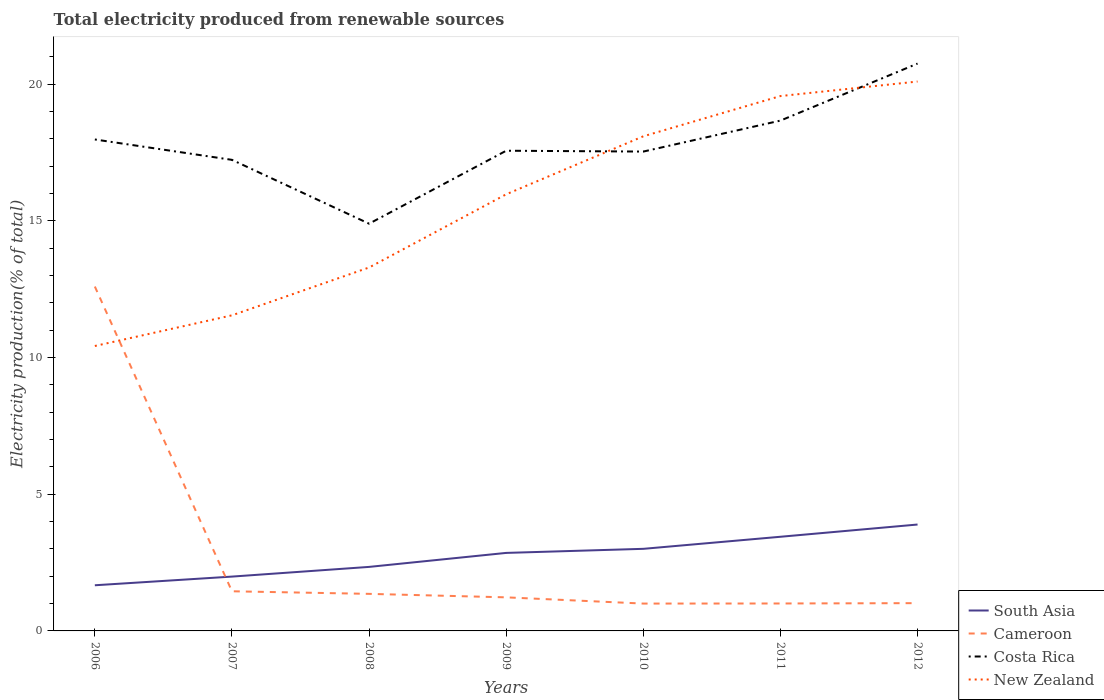How many different coloured lines are there?
Provide a succinct answer. 4. Is the number of lines equal to the number of legend labels?
Your answer should be compact. Yes. Across all years, what is the maximum total electricity produced in Cameroon?
Your response must be concise. 1. What is the total total electricity produced in Costa Rica in the graph?
Your answer should be compact. -3.52. What is the difference between the highest and the second highest total electricity produced in Cameroon?
Ensure brevity in your answer.  11.59. What is the difference between the highest and the lowest total electricity produced in Cameroon?
Give a very brief answer. 1. How are the legend labels stacked?
Offer a terse response. Vertical. What is the title of the graph?
Provide a succinct answer. Total electricity produced from renewable sources. Does "Andorra" appear as one of the legend labels in the graph?
Your answer should be compact. No. What is the Electricity production(% of total) of South Asia in 2006?
Your answer should be very brief. 1.67. What is the Electricity production(% of total) of Cameroon in 2006?
Keep it short and to the point. 12.59. What is the Electricity production(% of total) in Costa Rica in 2006?
Provide a short and direct response. 17.97. What is the Electricity production(% of total) of New Zealand in 2006?
Keep it short and to the point. 10.42. What is the Electricity production(% of total) in South Asia in 2007?
Offer a very short reply. 1.99. What is the Electricity production(% of total) in Cameroon in 2007?
Your answer should be compact. 1.45. What is the Electricity production(% of total) in Costa Rica in 2007?
Offer a terse response. 17.23. What is the Electricity production(% of total) of New Zealand in 2007?
Offer a very short reply. 11.54. What is the Electricity production(% of total) in South Asia in 2008?
Offer a terse response. 2.34. What is the Electricity production(% of total) in Cameroon in 2008?
Your answer should be compact. 1.36. What is the Electricity production(% of total) in Costa Rica in 2008?
Make the answer very short. 14.89. What is the Electricity production(% of total) in New Zealand in 2008?
Give a very brief answer. 13.29. What is the Electricity production(% of total) in South Asia in 2009?
Your answer should be very brief. 2.85. What is the Electricity production(% of total) of Cameroon in 2009?
Your answer should be compact. 1.23. What is the Electricity production(% of total) of Costa Rica in 2009?
Keep it short and to the point. 17.56. What is the Electricity production(% of total) of New Zealand in 2009?
Provide a succinct answer. 15.97. What is the Electricity production(% of total) in South Asia in 2010?
Keep it short and to the point. 3. What is the Electricity production(% of total) in Cameroon in 2010?
Your answer should be very brief. 1. What is the Electricity production(% of total) in Costa Rica in 2010?
Ensure brevity in your answer.  17.53. What is the Electricity production(% of total) of New Zealand in 2010?
Your response must be concise. 18.09. What is the Electricity production(% of total) in South Asia in 2011?
Your response must be concise. 3.44. What is the Electricity production(% of total) of Cameroon in 2011?
Make the answer very short. 1. What is the Electricity production(% of total) of Costa Rica in 2011?
Your answer should be very brief. 18.66. What is the Electricity production(% of total) in New Zealand in 2011?
Your answer should be compact. 19.56. What is the Electricity production(% of total) of South Asia in 2012?
Your response must be concise. 3.89. What is the Electricity production(% of total) of Cameroon in 2012?
Your response must be concise. 1.02. What is the Electricity production(% of total) in Costa Rica in 2012?
Your answer should be very brief. 20.75. What is the Electricity production(% of total) of New Zealand in 2012?
Offer a terse response. 20.09. Across all years, what is the maximum Electricity production(% of total) in South Asia?
Provide a succinct answer. 3.89. Across all years, what is the maximum Electricity production(% of total) in Cameroon?
Provide a short and direct response. 12.59. Across all years, what is the maximum Electricity production(% of total) of Costa Rica?
Keep it short and to the point. 20.75. Across all years, what is the maximum Electricity production(% of total) of New Zealand?
Offer a terse response. 20.09. Across all years, what is the minimum Electricity production(% of total) in South Asia?
Provide a short and direct response. 1.67. Across all years, what is the minimum Electricity production(% of total) in Cameroon?
Provide a short and direct response. 1. Across all years, what is the minimum Electricity production(% of total) of Costa Rica?
Provide a short and direct response. 14.89. Across all years, what is the minimum Electricity production(% of total) in New Zealand?
Give a very brief answer. 10.42. What is the total Electricity production(% of total) in South Asia in the graph?
Make the answer very short. 19.19. What is the total Electricity production(% of total) of Cameroon in the graph?
Your response must be concise. 19.64. What is the total Electricity production(% of total) in Costa Rica in the graph?
Offer a terse response. 124.59. What is the total Electricity production(% of total) in New Zealand in the graph?
Offer a very short reply. 108.95. What is the difference between the Electricity production(% of total) in South Asia in 2006 and that in 2007?
Provide a succinct answer. -0.32. What is the difference between the Electricity production(% of total) in Cameroon in 2006 and that in 2007?
Keep it short and to the point. 11.14. What is the difference between the Electricity production(% of total) in Costa Rica in 2006 and that in 2007?
Give a very brief answer. 0.75. What is the difference between the Electricity production(% of total) in New Zealand in 2006 and that in 2007?
Your answer should be very brief. -1.12. What is the difference between the Electricity production(% of total) of South Asia in 2006 and that in 2008?
Your answer should be very brief. -0.67. What is the difference between the Electricity production(% of total) of Cameroon in 2006 and that in 2008?
Your response must be concise. 11.24. What is the difference between the Electricity production(% of total) of Costa Rica in 2006 and that in 2008?
Your answer should be very brief. 3.08. What is the difference between the Electricity production(% of total) in New Zealand in 2006 and that in 2008?
Give a very brief answer. -2.87. What is the difference between the Electricity production(% of total) in South Asia in 2006 and that in 2009?
Keep it short and to the point. -1.18. What is the difference between the Electricity production(% of total) of Cameroon in 2006 and that in 2009?
Ensure brevity in your answer.  11.37. What is the difference between the Electricity production(% of total) in Costa Rica in 2006 and that in 2009?
Provide a short and direct response. 0.41. What is the difference between the Electricity production(% of total) in New Zealand in 2006 and that in 2009?
Give a very brief answer. -5.55. What is the difference between the Electricity production(% of total) in South Asia in 2006 and that in 2010?
Ensure brevity in your answer.  -1.33. What is the difference between the Electricity production(% of total) of Cameroon in 2006 and that in 2010?
Provide a succinct answer. 11.59. What is the difference between the Electricity production(% of total) of Costa Rica in 2006 and that in 2010?
Provide a short and direct response. 0.44. What is the difference between the Electricity production(% of total) in New Zealand in 2006 and that in 2010?
Keep it short and to the point. -7.67. What is the difference between the Electricity production(% of total) in South Asia in 2006 and that in 2011?
Offer a terse response. -1.77. What is the difference between the Electricity production(% of total) in Cameroon in 2006 and that in 2011?
Give a very brief answer. 11.59. What is the difference between the Electricity production(% of total) in Costa Rica in 2006 and that in 2011?
Offer a terse response. -0.69. What is the difference between the Electricity production(% of total) of New Zealand in 2006 and that in 2011?
Provide a succinct answer. -9.14. What is the difference between the Electricity production(% of total) in South Asia in 2006 and that in 2012?
Make the answer very short. -2.22. What is the difference between the Electricity production(% of total) of Cameroon in 2006 and that in 2012?
Your answer should be compact. 11.58. What is the difference between the Electricity production(% of total) in Costa Rica in 2006 and that in 2012?
Make the answer very short. -2.78. What is the difference between the Electricity production(% of total) of New Zealand in 2006 and that in 2012?
Your answer should be compact. -9.67. What is the difference between the Electricity production(% of total) of South Asia in 2007 and that in 2008?
Provide a succinct answer. -0.35. What is the difference between the Electricity production(% of total) of Cameroon in 2007 and that in 2008?
Offer a very short reply. 0.09. What is the difference between the Electricity production(% of total) in Costa Rica in 2007 and that in 2008?
Give a very brief answer. 2.33. What is the difference between the Electricity production(% of total) in New Zealand in 2007 and that in 2008?
Provide a short and direct response. -1.75. What is the difference between the Electricity production(% of total) in South Asia in 2007 and that in 2009?
Give a very brief answer. -0.87. What is the difference between the Electricity production(% of total) of Cameroon in 2007 and that in 2009?
Offer a terse response. 0.22. What is the difference between the Electricity production(% of total) of Costa Rica in 2007 and that in 2009?
Ensure brevity in your answer.  -0.33. What is the difference between the Electricity production(% of total) in New Zealand in 2007 and that in 2009?
Give a very brief answer. -4.43. What is the difference between the Electricity production(% of total) of South Asia in 2007 and that in 2010?
Ensure brevity in your answer.  -1.01. What is the difference between the Electricity production(% of total) in Cameroon in 2007 and that in 2010?
Ensure brevity in your answer.  0.45. What is the difference between the Electricity production(% of total) in Costa Rica in 2007 and that in 2010?
Make the answer very short. -0.3. What is the difference between the Electricity production(% of total) in New Zealand in 2007 and that in 2010?
Keep it short and to the point. -6.55. What is the difference between the Electricity production(% of total) in South Asia in 2007 and that in 2011?
Keep it short and to the point. -1.46. What is the difference between the Electricity production(% of total) in Cameroon in 2007 and that in 2011?
Offer a very short reply. 0.45. What is the difference between the Electricity production(% of total) of Costa Rica in 2007 and that in 2011?
Offer a very short reply. -1.44. What is the difference between the Electricity production(% of total) of New Zealand in 2007 and that in 2011?
Give a very brief answer. -8.02. What is the difference between the Electricity production(% of total) of South Asia in 2007 and that in 2012?
Offer a terse response. -1.9. What is the difference between the Electricity production(% of total) of Cameroon in 2007 and that in 2012?
Provide a short and direct response. 0.43. What is the difference between the Electricity production(% of total) of Costa Rica in 2007 and that in 2012?
Provide a short and direct response. -3.52. What is the difference between the Electricity production(% of total) in New Zealand in 2007 and that in 2012?
Offer a terse response. -8.55. What is the difference between the Electricity production(% of total) of South Asia in 2008 and that in 2009?
Your response must be concise. -0.51. What is the difference between the Electricity production(% of total) of Cameroon in 2008 and that in 2009?
Keep it short and to the point. 0.13. What is the difference between the Electricity production(% of total) in Costa Rica in 2008 and that in 2009?
Ensure brevity in your answer.  -2.67. What is the difference between the Electricity production(% of total) in New Zealand in 2008 and that in 2009?
Offer a very short reply. -2.68. What is the difference between the Electricity production(% of total) of South Asia in 2008 and that in 2010?
Your answer should be compact. -0.66. What is the difference between the Electricity production(% of total) of Cameroon in 2008 and that in 2010?
Ensure brevity in your answer.  0.36. What is the difference between the Electricity production(% of total) in Costa Rica in 2008 and that in 2010?
Keep it short and to the point. -2.64. What is the difference between the Electricity production(% of total) of New Zealand in 2008 and that in 2010?
Give a very brief answer. -4.8. What is the difference between the Electricity production(% of total) of South Asia in 2008 and that in 2011?
Keep it short and to the point. -1.1. What is the difference between the Electricity production(% of total) in Cameroon in 2008 and that in 2011?
Your answer should be very brief. 0.35. What is the difference between the Electricity production(% of total) in Costa Rica in 2008 and that in 2011?
Your answer should be very brief. -3.77. What is the difference between the Electricity production(% of total) of New Zealand in 2008 and that in 2011?
Your answer should be compact. -6.27. What is the difference between the Electricity production(% of total) of South Asia in 2008 and that in 2012?
Keep it short and to the point. -1.55. What is the difference between the Electricity production(% of total) of Cameroon in 2008 and that in 2012?
Ensure brevity in your answer.  0.34. What is the difference between the Electricity production(% of total) in Costa Rica in 2008 and that in 2012?
Your answer should be compact. -5.86. What is the difference between the Electricity production(% of total) of New Zealand in 2008 and that in 2012?
Your answer should be very brief. -6.8. What is the difference between the Electricity production(% of total) in South Asia in 2009 and that in 2010?
Provide a succinct answer. -0.15. What is the difference between the Electricity production(% of total) in Cameroon in 2009 and that in 2010?
Your answer should be compact. 0.23. What is the difference between the Electricity production(% of total) of Costa Rica in 2009 and that in 2010?
Your answer should be very brief. 0.03. What is the difference between the Electricity production(% of total) of New Zealand in 2009 and that in 2010?
Your response must be concise. -2.12. What is the difference between the Electricity production(% of total) in South Asia in 2009 and that in 2011?
Provide a short and direct response. -0.59. What is the difference between the Electricity production(% of total) of Cameroon in 2009 and that in 2011?
Make the answer very short. 0.22. What is the difference between the Electricity production(% of total) in Costa Rica in 2009 and that in 2011?
Provide a succinct answer. -1.1. What is the difference between the Electricity production(% of total) in New Zealand in 2009 and that in 2011?
Give a very brief answer. -3.59. What is the difference between the Electricity production(% of total) in South Asia in 2009 and that in 2012?
Make the answer very short. -1.04. What is the difference between the Electricity production(% of total) of Cameroon in 2009 and that in 2012?
Your answer should be very brief. 0.21. What is the difference between the Electricity production(% of total) in Costa Rica in 2009 and that in 2012?
Provide a succinct answer. -3.19. What is the difference between the Electricity production(% of total) in New Zealand in 2009 and that in 2012?
Provide a succinct answer. -4.12. What is the difference between the Electricity production(% of total) of South Asia in 2010 and that in 2011?
Offer a very short reply. -0.44. What is the difference between the Electricity production(% of total) of Cameroon in 2010 and that in 2011?
Make the answer very short. -0. What is the difference between the Electricity production(% of total) in Costa Rica in 2010 and that in 2011?
Your answer should be compact. -1.13. What is the difference between the Electricity production(% of total) in New Zealand in 2010 and that in 2011?
Your answer should be very brief. -1.47. What is the difference between the Electricity production(% of total) in South Asia in 2010 and that in 2012?
Your answer should be compact. -0.89. What is the difference between the Electricity production(% of total) in Cameroon in 2010 and that in 2012?
Give a very brief answer. -0.02. What is the difference between the Electricity production(% of total) of Costa Rica in 2010 and that in 2012?
Your response must be concise. -3.22. What is the difference between the Electricity production(% of total) of New Zealand in 2010 and that in 2012?
Give a very brief answer. -2. What is the difference between the Electricity production(% of total) in South Asia in 2011 and that in 2012?
Your response must be concise. -0.45. What is the difference between the Electricity production(% of total) in Cameroon in 2011 and that in 2012?
Offer a very short reply. -0.01. What is the difference between the Electricity production(% of total) in Costa Rica in 2011 and that in 2012?
Offer a terse response. -2.09. What is the difference between the Electricity production(% of total) in New Zealand in 2011 and that in 2012?
Offer a terse response. -0.53. What is the difference between the Electricity production(% of total) in South Asia in 2006 and the Electricity production(% of total) in Cameroon in 2007?
Your answer should be very brief. 0.22. What is the difference between the Electricity production(% of total) of South Asia in 2006 and the Electricity production(% of total) of Costa Rica in 2007?
Offer a very short reply. -15.56. What is the difference between the Electricity production(% of total) in South Asia in 2006 and the Electricity production(% of total) in New Zealand in 2007?
Make the answer very short. -9.87. What is the difference between the Electricity production(% of total) in Cameroon in 2006 and the Electricity production(% of total) in Costa Rica in 2007?
Keep it short and to the point. -4.63. What is the difference between the Electricity production(% of total) in Cameroon in 2006 and the Electricity production(% of total) in New Zealand in 2007?
Your answer should be very brief. 1.05. What is the difference between the Electricity production(% of total) in Costa Rica in 2006 and the Electricity production(% of total) in New Zealand in 2007?
Ensure brevity in your answer.  6.43. What is the difference between the Electricity production(% of total) of South Asia in 2006 and the Electricity production(% of total) of Cameroon in 2008?
Keep it short and to the point. 0.31. What is the difference between the Electricity production(% of total) of South Asia in 2006 and the Electricity production(% of total) of Costa Rica in 2008?
Ensure brevity in your answer.  -13.22. What is the difference between the Electricity production(% of total) in South Asia in 2006 and the Electricity production(% of total) in New Zealand in 2008?
Provide a succinct answer. -11.62. What is the difference between the Electricity production(% of total) of Cameroon in 2006 and the Electricity production(% of total) of Costa Rica in 2008?
Provide a succinct answer. -2.3. What is the difference between the Electricity production(% of total) in Cameroon in 2006 and the Electricity production(% of total) in New Zealand in 2008?
Ensure brevity in your answer.  -0.7. What is the difference between the Electricity production(% of total) in Costa Rica in 2006 and the Electricity production(% of total) in New Zealand in 2008?
Keep it short and to the point. 4.68. What is the difference between the Electricity production(% of total) of South Asia in 2006 and the Electricity production(% of total) of Cameroon in 2009?
Keep it short and to the point. 0.44. What is the difference between the Electricity production(% of total) of South Asia in 2006 and the Electricity production(% of total) of Costa Rica in 2009?
Give a very brief answer. -15.89. What is the difference between the Electricity production(% of total) in South Asia in 2006 and the Electricity production(% of total) in New Zealand in 2009?
Your answer should be compact. -14.3. What is the difference between the Electricity production(% of total) of Cameroon in 2006 and the Electricity production(% of total) of Costa Rica in 2009?
Offer a very short reply. -4.97. What is the difference between the Electricity production(% of total) of Cameroon in 2006 and the Electricity production(% of total) of New Zealand in 2009?
Offer a very short reply. -3.37. What is the difference between the Electricity production(% of total) in Costa Rica in 2006 and the Electricity production(% of total) in New Zealand in 2009?
Provide a succinct answer. 2. What is the difference between the Electricity production(% of total) in South Asia in 2006 and the Electricity production(% of total) in Cameroon in 2010?
Your response must be concise. 0.67. What is the difference between the Electricity production(% of total) in South Asia in 2006 and the Electricity production(% of total) in Costa Rica in 2010?
Keep it short and to the point. -15.86. What is the difference between the Electricity production(% of total) of South Asia in 2006 and the Electricity production(% of total) of New Zealand in 2010?
Your answer should be very brief. -16.42. What is the difference between the Electricity production(% of total) in Cameroon in 2006 and the Electricity production(% of total) in Costa Rica in 2010?
Your answer should be very brief. -4.94. What is the difference between the Electricity production(% of total) in Cameroon in 2006 and the Electricity production(% of total) in New Zealand in 2010?
Provide a short and direct response. -5.49. What is the difference between the Electricity production(% of total) of Costa Rica in 2006 and the Electricity production(% of total) of New Zealand in 2010?
Make the answer very short. -0.12. What is the difference between the Electricity production(% of total) in South Asia in 2006 and the Electricity production(% of total) in Cameroon in 2011?
Keep it short and to the point. 0.67. What is the difference between the Electricity production(% of total) of South Asia in 2006 and the Electricity production(% of total) of Costa Rica in 2011?
Give a very brief answer. -16.99. What is the difference between the Electricity production(% of total) in South Asia in 2006 and the Electricity production(% of total) in New Zealand in 2011?
Your answer should be very brief. -17.89. What is the difference between the Electricity production(% of total) of Cameroon in 2006 and the Electricity production(% of total) of Costa Rica in 2011?
Your answer should be compact. -6.07. What is the difference between the Electricity production(% of total) in Cameroon in 2006 and the Electricity production(% of total) in New Zealand in 2011?
Offer a terse response. -6.97. What is the difference between the Electricity production(% of total) in Costa Rica in 2006 and the Electricity production(% of total) in New Zealand in 2011?
Provide a succinct answer. -1.59. What is the difference between the Electricity production(% of total) of South Asia in 2006 and the Electricity production(% of total) of Cameroon in 2012?
Offer a terse response. 0.65. What is the difference between the Electricity production(% of total) of South Asia in 2006 and the Electricity production(% of total) of Costa Rica in 2012?
Ensure brevity in your answer.  -19.08. What is the difference between the Electricity production(% of total) in South Asia in 2006 and the Electricity production(% of total) in New Zealand in 2012?
Your answer should be compact. -18.42. What is the difference between the Electricity production(% of total) in Cameroon in 2006 and the Electricity production(% of total) in Costa Rica in 2012?
Provide a short and direct response. -8.15. What is the difference between the Electricity production(% of total) of Cameroon in 2006 and the Electricity production(% of total) of New Zealand in 2012?
Offer a terse response. -7.5. What is the difference between the Electricity production(% of total) in Costa Rica in 2006 and the Electricity production(% of total) in New Zealand in 2012?
Give a very brief answer. -2.12. What is the difference between the Electricity production(% of total) of South Asia in 2007 and the Electricity production(% of total) of Cameroon in 2008?
Offer a very short reply. 0.63. What is the difference between the Electricity production(% of total) of South Asia in 2007 and the Electricity production(% of total) of Costa Rica in 2008?
Your response must be concise. -12.9. What is the difference between the Electricity production(% of total) in South Asia in 2007 and the Electricity production(% of total) in New Zealand in 2008?
Ensure brevity in your answer.  -11.3. What is the difference between the Electricity production(% of total) in Cameroon in 2007 and the Electricity production(% of total) in Costa Rica in 2008?
Your response must be concise. -13.44. What is the difference between the Electricity production(% of total) in Cameroon in 2007 and the Electricity production(% of total) in New Zealand in 2008?
Offer a terse response. -11.84. What is the difference between the Electricity production(% of total) of Costa Rica in 2007 and the Electricity production(% of total) of New Zealand in 2008?
Make the answer very short. 3.94. What is the difference between the Electricity production(% of total) in South Asia in 2007 and the Electricity production(% of total) in Cameroon in 2009?
Your response must be concise. 0.76. What is the difference between the Electricity production(% of total) of South Asia in 2007 and the Electricity production(% of total) of Costa Rica in 2009?
Ensure brevity in your answer.  -15.57. What is the difference between the Electricity production(% of total) of South Asia in 2007 and the Electricity production(% of total) of New Zealand in 2009?
Offer a very short reply. -13.98. What is the difference between the Electricity production(% of total) in Cameroon in 2007 and the Electricity production(% of total) in Costa Rica in 2009?
Make the answer very short. -16.11. What is the difference between the Electricity production(% of total) of Cameroon in 2007 and the Electricity production(% of total) of New Zealand in 2009?
Your response must be concise. -14.52. What is the difference between the Electricity production(% of total) in Costa Rica in 2007 and the Electricity production(% of total) in New Zealand in 2009?
Provide a succinct answer. 1.26. What is the difference between the Electricity production(% of total) of South Asia in 2007 and the Electricity production(% of total) of Cameroon in 2010?
Offer a terse response. 0.99. What is the difference between the Electricity production(% of total) in South Asia in 2007 and the Electricity production(% of total) in Costa Rica in 2010?
Provide a short and direct response. -15.54. What is the difference between the Electricity production(% of total) in South Asia in 2007 and the Electricity production(% of total) in New Zealand in 2010?
Your response must be concise. -16.1. What is the difference between the Electricity production(% of total) in Cameroon in 2007 and the Electricity production(% of total) in Costa Rica in 2010?
Your answer should be very brief. -16.08. What is the difference between the Electricity production(% of total) of Cameroon in 2007 and the Electricity production(% of total) of New Zealand in 2010?
Offer a terse response. -16.64. What is the difference between the Electricity production(% of total) of Costa Rica in 2007 and the Electricity production(% of total) of New Zealand in 2010?
Keep it short and to the point. -0.86. What is the difference between the Electricity production(% of total) in South Asia in 2007 and the Electricity production(% of total) in Cameroon in 2011?
Offer a very short reply. 0.98. What is the difference between the Electricity production(% of total) in South Asia in 2007 and the Electricity production(% of total) in Costa Rica in 2011?
Keep it short and to the point. -16.67. What is the difference between the Electricity production(% of total) of South Asia in 2007 and the Electricity production(% of total) of New Zealand in 2011?
Keep it short and to the point. -17.57. What is the difference between the Electricity production(% of total) in Cameroon in 2007 and the Electricity production(% of total) in Costa Rica in 2011?
Ensure brevity in your answer.  -17.21. What is the difference between the Electricity production(% of total) of Cameroon in 2007 and the Electricity production(% of total) of New Zealand in 2011?
Keep it short and to the point. -18.11. What is the difference between the Electricity production(% of total) of Costa Rica in 2007 and the Electricity production(% of total) of New Zealand in 2011?
Offer a very short reply. -2.33. What is the difference between the Electricity production(% of total) of South Asia in 2007 and the Electricity production(% of total) of Cameroon in 2012?
Give a very brief answer. 0.97. What is the difference between the Electricity production(% of total) of South Asia in 2007 and the Electricity production(% of total) of Costa Rica in 2012?
Your response must be concise. -18.76. What is the difference between the Electricity production(% of total) in South Asia in 2007 and the Electricity production(% of total) in New Zealand in 2012?
Give a very brief answer. -18.1. What is the difference between the Electricity production(% of total) of Cameroon in 2007 and the Electricity production(% of total) of Costa Rica in 2012?
Your answer should be very brief. -19.3. What is the difference between the Electricity production(% of total) of Cameroon in 2007 and the Electricity production(% of total) of New Zealand in 2012?
Make the answer very short. -18.64. What is the difference between the Electricity production(% of total) of Costa Rica in 2007 and the Electricity production(% of total) of New Zealand in 2012?
Give a very brief answer. -2.86. What is the difference between the Electricity production(% of total) of South Asia in 2008 and the Electricity production(% of total) of Cameroon in 2009?
Provide a short and direct response. 1.11. What is the difference between the Electricity production(% of total) in South Asia in 2008 and the Electricity production(% of total) in Costa Rica in 2009?
Offer a terse response. -15.22. What is the difference between the Electricity production(% of total) in South Asia in 2008 and the Electricity production(% of total) in New Zealand in 2009?
Your answer should be compact. -13.63. What is the difference between the Electricity production(% of total) in Cameroon in 2008 and the Electricity production(% of total) in Costa Rica in 2009?
Provide a succinct answer. -16.2. What is the difference between the Electricity production(% of total) of Cameroon in 2008 and the Electricity production(% of total) of New Zealand in 2009?
Provide a short and direct response. -14.61. What is the difference between the Electricity production(% of total) of Costa Rica in 2008 and the Electricity production(% of total) of New Zealand in 2009?
Your response must be concise. -1.07. What is the difference between the Electricity production(% of total) in South Asia in 2008 and the Electricity production(% of total) in Cameroon in 2010?
Offer a terse response. 1.34. What is the difference between the Electricity production(% of total) in South Asia in 2008 and the Electricity production(% of total) in Costa Rica in 2010?
Your response must be concise. -15.19. What is the difference between the Electricity production(% of total) in South Asia in 2008 and the Electricity production(% of total) in New Zealand in 2010?
Provide a short and direct response. -15.75. What is the difference between the Electricity production(% of total) in Cameroon in 2008 and the Electricity production(% of total) in Costa Rica in 2010?
Give a very brief answer. -16.17. What is the difference between the Electricity production(% of total) in Cameroon in 2008 and the Electricity production(% of total) in New Zealand in 2010?
Your answer should be very brief. -16.73. What is the difference between the Electricity production(% of total) in Costa Rica in 2008 and the Electricity production(% of total) in New Zealand in 2010?
Ensure brevity in your answer.  -3.2. What is the difference between the Electricity production(% of total) of South Asia in 2008 and the Electricity production(% of total) of Cameroon in 2011?
Ensure brevity in your answer.  1.34. What is the difference between the Electricity production(% of total) of South Asia in 2008 and the Electricity production(% of total) of Costa Rica in 2011?
Provide a short and direct response. -16.32. What is the difference between the Electricity production(% of total) of South Asia in 2008 and the Electricity production(% of total) of New Zealand in 2011?
Give a very brief answer. -17.22. What is the difference between the Electricity production(% of total) in Cameroon in 2008 and the Electricity production(% of total) in Costa Rica in 2011?
Offer a very short reply. -17.31. What is the difference between the Electricity production(% of total) of Cameroon in 2008 and the Electricity production(% of total) of New Zealand in 2011?
Your response must be concise. -18.2. What is the difference between the Electricity production(% of total) of Costa Rica in 2008 and the Electricity production(% of total) of New Zealand in 2011?
Provide a succinct answer. -4.67. What is the difference between the Electricity production(% of total) in South Asia in 2008 and the Electricity production(% of total) in Cameroon in 2012?
Provide a succinct answer. 1.33. What is the difference between the Electricity production(% of total) of South Asia in 2008 and the Electricity production(% of total) of Costa Rica in 2012?
Your answer should be very brief. -18.41. What is the difference between the Electricity production(% of total) of South Asia in 2008 and the Electricity production(% of total) of New Zealand in 2012?
Offer a terse response. -17.75. What is the difference between the Electricity production(% of total) of Cameroon in 2008 and the Electricity production(% of total) of Costa Rica in 2012?
Give a very brief answer. -19.39. What is the difference between the Electricity production(% of total) of Cameroon in 2008 and the Electricity production(% of total) of New Zealand in 2012?
Offer a very short reply. -18.73. What is the difference between the Electricity production(% of total) of Costa Rica in 2008 and the Electricity production(% of total) of New Zealand in 2012?
Your answer should be compact. -5.2. What is the difference between the Electricity production(% of total) of South Asia in 2009 and the Electricity production(% of total) of Cameroon in 2010?
Your answer should be compact. 1.85. What is the difference between the Electricity production(% of total) in South Asia in 2009 and the Electricity production(% of total) in Costa Rica in 2010?
Provide a succinct answer. -14.68. What is the difference between the Electricity production(% of total) in South Asia in 2009 and the Electricity production(% of total) in New Zealand in 2010?
Provide a succinct answer. -15.23. What is the difference between the Electricity production(% of total) in Cameroon in 2009 and the Electricity production(% of total) in Costa Rica in 2010?
Provide a short and direct response. -16.3. What is the difference between the Electricity production(% of total) in Cameroon in 2009 and the Electricity production(% of total) in New Zealand in 2010?
Provide a succinct answer. -16.86. What is the difference between the Electricity production(% of total) of Costa Rica in 2009 and the Electricity production(% of total) of New Zealand in 2010?
Ensure brevity in your answer.  -0.53. What is the difference between the Electricity production(% of total) in South Asia in 2009 and the Electricity production(% of total) in Cameroon in 2011?
Provide a succinct answer. 1.85. What is the difference between the Electricity production(% of total) in South Asia in 2009 and the Electricity production(% of total) in Costa Rica in 2011?
Provide a succinct answer. -15.81. What is the difference between the Electricity production(% of total) of South Asia in 2009 and the Electricity production(% of total) of New Zealand in 2011?
Give a very brief answer. -16.71. What is the difference between the Electricity production(% of total) in Cameroon in 2009 and the Electricity production(% of total) in Costa Rica in 2011?
Your answer should be very brief. -17.43. What is the difference between the Electricity production(% of total) of Cameroon in 2009 and the Electricity production(% of total) of New Zealand in 2011?
Your response must be concise. -18.33. What is the difference between the Electricity production(% of total) of Costa Rica in 2009 and the Electricity production(% of total) of New Zealand in 2011?
Provide a short and direct response. -2. What is the difference between the Electricity production(% of total) in South Asia in 2009 and the Electricity production(% of total) in Cameroon in 2012?
Your answer should be very brief. 1.84. What is the difference between the Electricity production(% of total) in South Asia in 2009 and the Electricity production(% of total) in Costa Rica in 2012?
Provide a succinct answer. -17.89. What is the difference between the Electricity production(% of total) in South Asia in 2009 and the Electricity production(% of total) in New Zealand in 2012?
Provide a succinct answer. -17.24. What is the difference between the Electricity production(% of total) of Cameroon in 2009 and the Electricity production(% of total) of Costa Rica in 2012?
Your answer should be compact. -19.52. What is the difference between the Electricity production(% of total) in Cameroon in 2009 and the Electricity production(% of total) in New Zealand in 2012?
Your response must be concise. -18.86. What is the difference between the Electricity production(% of total) in Costa Rica in 2009 and the Electricity production(% of total) in New Zealand in 2012?
Your response must be concise. -2.53. What is the difference between the Electricity production(% of total) of South Asia in 2010 and the Electricity production(% of total) of Cameroon in 2011?
Provide a short and direct response. 2. What is the difference between the Electricity production(% of total) of South Asia in 2010 and the Electricity production(% of total) of Costa Rica in 2011?
Make the answer very short. -15.66. What is the difference between the Electricity production(% of total) of South Asia in 2010 and the Electricity production(% of total) of New Zealand in 2011?
Ensure brevity in your answer.  -16.56. What is the difference between the Electricity production(% of total) in Cameroon in 2010 and the Electricity production(% of total) in Costa Rica in 2011?
Give a very brief answer. -17.66. What is the difference between the Electricity production(% of total) of Cameroon in 2010 and the Electricity production(% of total) of New Zealand in 2011?
Ensure brevity in your answer.  -18.56. What is the difference between the Electricity production(% of total) in Costa Rica in 2010 and the Electricity production(% of total) in New Zealand in 2011?
Give a very brief answer. -2.03. What is the difference between the Electricity production(% of total) in South Asia in 2010 and the Electricity production(% of total) in Cameroon in 2012?
Provide a short and direct response. 1.99. What is the difference between the Electricity production(% of total) in South Asia in 2010 and the Electricity production(% of total) in Costa Rica in 2012?
Your answer should be very brief. -17.75. What is the difference between the Electricity production(% of total) in South Asia in 2010 and the Electricity production(% of total) in New Zealand in 2012?
Keep it short and to the point. -17.09. What is the difference between the Electricity production(% of total) of Cameroon in 2010 and the Electricity production(% of total) of Costa Rica in 2012?
Offer a terse response. -19.75. What is the difference between the Electricity production(% of total) in Cameroon in 2010 and the Electricity production(% of total) in New Zealand in 2012?
Provide a short and direct response. -19.09. What is the difference between the Electricity production(% of total) of Costa Rica in 2010 and the Electricity production(% of total) of New Zealand in 2012?
Keep it short and to the point. -2.56. What is the difference between the Electricity production(% of total) in South Asia in 2011 and the Electricity production(% of total) in Cameroon in 2012?
Make the answer very short. 2.43. What is the difference between the Electricity production(% of total) in South Asia in 2011 and the Electricity production(% of total) in Costa Rica in 2012?
Keep it short and to the point. -17.3. What is the difference between the Electricity production(% of total) of South Asia in 2011 and the Electricity production(% of total) of New Zealand in 2012?
Your answer should be compact. -16.65. What is the difference between the Electricity production(% of total) in Cameroon in 2011 and the Electricity production(% of total) in Costa Rica in 2012?
Provide a short and direct response. -19.74. What is the difference between the Electricity production(% of total) of Cameroon in 2011 and the Electricity production(% of total) of New Zealand in 2012?
Make the answer very short. -19.09. What is the difference between the Electricity production(% of total) in Costa Rica in 2011 and the Electricity production(% of total) in New Zealand in 2012?
Give a very brief answer. -1.43. What is the average Electricity production(% of total) in South Asia per year?
Ensure brevity in your answer.  2.74. What is the average Electricity production(% of total) in Cameroon per year?
Your answer should be very brief. 2.81. What is the average Electricity production(% of total) in Costa Rica per year?
Make the answer very short. 17.8. What is the average Electricity production(% of total) of New Zealand per year?
Give a very brief answer. 15.56. In the year 2006, what is the difference between the Electricity production(% of total) of South Asia and Electricity production(% of total) of Cameroon?
Your response must be concise. -10.92. In the year 2006, what is the difference between the Electricity production(% of total) of South Asia and Electricity production(% of total) of Costa Rica?
Your answer should be compact. -16.3. In the year 2006, what is the difference between the Electricity production(% of total) in South Asia and Electricity production(% of total) in New Zealand?
Your response must be concise. -8.75. In the year 2006, what is the difference between the Electricity production(% of total) of Cameroon and Electricity production(% of total) of Costa Rica?
Offer a very short reply. -5.38. In the year 2006, what is the difference between the Electricity production(% of total) in Cameroon and Electricity production(% of total) in New Zealand?
Make the answer very short. 2.17. In the year 2006, what is the difference between the Electricity production(% of total) in Costa Rica and Electricity production(% of total) in New Zealand?
Provide a succinct answer. 7.55. In the year 2007, what is the difference between the Electricity production(% of total) in South Asia and Electricity production(% of total) in Cameroon?
Give a very brief answer. 0.54. In the year 2007, what is the difference between the Electricity production(% of total) in South Asia and Electricity production(% of total) in Costa Rica?
Offer a terse response. -15.24. In the year 2007, what is the difference between the Electricity production(% of total) of South Asia and Electricity production(% of total) of New Zealand?
Your answer should be very brief. -9.55. In the year 2007, what is the difference between the Electricity production(% of total) in Cameroon and Electricity production(% of total) in Costa Rica?
Your response must be concise. -15.78. In the year 2007, what is the difference between the Electricity production(% of total) of Cameroon and Electricity production(% of total) of New Zealand?
Offer a terse response. -10.09. In the year 2007, what is the difference between the Electricity production(% of total) in Costa Rica and Electricity production(% of total) in New Zealand?
Provide a succinct answer. 5.69. In the year 2008, what is the difference between the Electricity production(% of total) in South Asia and Electricity production(% of total) in Cameroon?
Give a very brief answer. 0.99. In the year 2008, what is the difference between the Electricity production(% of total) of South Asia and Electricity production(% of total) of Costa Rica?
Ensure brevity in your answer.  -12.55. In the year 2008, what is the difference between the Electricity production(% of total) in South Asia and Electricity production(% of total) in New Zealand?
Your response must be concise. -10.95. In the year 2008, what is the difference between the Electricity production(% of total) of Cameroon and Electricity production(% of total) of Costa Rica?
Give a very brief answer. -13.54. In the year 2008, what is the difference between the Electricity production(% of total) of Cameroon and Electricity production(% of total) of New Zealand?
Provide a short and direct response. -11.93. In the year 2008, what is the difference between the Electricity production(% of total) of Costa Rica and Electricity production(% of total) of New Zealand?
Provide a short and direct response. 1.6. In the year 2009, what is the difference between the Electricity production(% of total) of South Asia and Electricity production(% of total) of Cameroon?
Make the answer very short. 1.63. In the year 2009, what is the difference between the Electricity production(% of total) of South Asia and Electricity production(% of total) of Costa Rica?
Your answer should be compact. -14.71. In the year 2009, what is the difference between the Electricity production(% of total) in South Asia and Electricity production(% of total) in New Zealand?
Ensure brevity in your answer.  -13.11. In the year 2009, what is the difference between the Electricity production(% of total) in Cameroon and Electricity production(% of total) in Costa Rica?
Your answer should be very brief. -16.33. In the year 2009, what is the difference between the Electricity production(% of total) in Cameroon and Electricity production(% of total) in New Zealand?
Ensure brevity in your answer.  -14.74. In the year 2009, what is the difference between the Electricity production(% of total) of Costa Rica and Electricity production(% of total) of New Zealand?
Offer a terse response. 1.59. In the year 2010, what is the difference between the Electricity production(% of total) of South Asia and Electricity production(% of total) of Cameroon?
Ensure brevity in your answer.  2. In the year 2010, what is the difference between the Electricity production(% of total) of South Asia and Electricity production(% of total) of Costa Rica?
Keep it short and to the point. -14.53. In the year 2010, what is the difference between the Electricity production(% of total) of South Asia and Electricity production(% of total) of New Zealand?
Make the answer very short. -15.09. In the year 2010, what is the difference between the Electricity production(% of total) in Cameroon and Electricity production(% of total) in Costa Rica?
Provide a short and direct response. -16.53. In the year 2010, what is the difference between the Electricity production(% of total) of Cameroon and Electricity production(% of total) of New Zealand?
Your response must be concise. -17.09. In the year 2010, what is the difference between the Electricity production(% of total) of Costa Rica and Electricity production(% of total) of New Zealand?
Offer a very short reply. -0.56. In the year 2011, what is the difference between the Electricity production(% of total) in South Asia and Electricity production(% of total) in Cameroon?
Give a very brief answer. 2.44. In the year 2011, what is the difference between the Electricity production(% of total) in South Asia and Electricity production(% of total) in Costa Rica?
Your answer should be very brief. -15.22. In the year 2011, what is the difference between the Electricity production(% of total) in South Asia and Electricity production(% of total) in New Zealand?
Provide a short and direct response. -16.12. In the year 2011, what is the difference between the Electricity production(% of total) of Cameroon and Electricity production(% of total) of Costa Rica?
Offer a terse response. -17.66. In the year 2011, what is the difference between the Electricity production(% of total) in Cameroon and Electricity production(% of total) in New Zealand?
Give a very brief answer. -18.56. In the year 2011, what is the difference between the Electricity production(% of total) in Costa Rica and Electricity production(% of total) in New Zealand?
Offer a terse response. -0.9. In the year 2012, what is the difference between the Electricity production(% of total) in South Asia and Electricity production(% of total) in Cameroon?
Your response must be concise. 2.88. In the year 2012, what is the difference between the Electricity production(% of total) in South Asia and Electricity production(% of total) in Costa Rica?
Your answer should be compact. -16.86. In the year 2012, what is the difference between the Electricity production(% of total) in South Asia and Electricity production(% of total) in New Zealand?
Your answer should be very brief. -16.2. In the year 2012, what is the difference between the Electricity production(% of total) in Cameroon and Electricity production(% of total) in Costa Rica?
Make the answer very short. -19.73. In the year 2012, what is the difference between the Electricity production(% of total) in Cameroon and Electricity production(% of total) in New Zealand?
Your answer should be compact. -19.07. In the year 2012, what is the difference between the Electricity production(% of total) of Costa Rica and Electricity production(% of total) of New Zealand?
Ensure brevity in your answer.  0.66. What is the ratio of the Electricity production(% of total) of South Asia in 2006 to that in 2007?
Provide a short and direct response. 0.84. What is the ratio of the Electricity production(% of total) in Cameroon in 2006 to that in 2007?
Give a very brief answer. 8.69. What is the ratio of the Electricity production(% of total) of Costa Rica in 2006 to that in 2007?
Make the answer very short. 1.04. What is the ratio of the Electricity production(% of total) of New Zealand in 2006 to that in 2007?
Your answer should be very brief. 0.9. What is the ratio of the Electricity production(% of total) in South Asia in 2006 to that in 2008?
Keep it short and to the point. 0.71. What is the ratio of the Electricity production(% of total) of Cameroon in 2006 to that in 2008?
Offer a very short reply. 9.29. What is the ratio of the Electricity production(% of total) of Costa Rica in 2006 to that in 2008?
Your response must be concise. 1.21. What is the ratio of the Electricity production(% of total) of New Zealand in 2006 to that in 2008?
Your response must be concise. 0.78. What is the ratio of the Electricity production(% of total) of South Asia in 2006 to that in 2009?
Your response must be concise. 0.59. What is the ratio of the Electricity production(% of total) in Cameroon in 2006 to that in 2009?
Provide a short and direct response. 10.26. What is the ratio of the Electricity production(% of total) of Costa Rica in 2006 to that in 2009?
Your response must be concise. 1.02. What is the ratio of the Electricity production(% of total) in New Zealand in 2006 to that in 2009?
Your answer should be compact. 0.65. What is the ratio of the Electricity production(% of total) of South Asia in 2006 to that in 2010?
Give a very brief answer. 0.56. What is the ratio of the Electricity production(% of total) of Cameroon in 2006 to that in 2010?
Offer a very short reply. 12.59. What is the ratio of the Electricity production(% of total) of Costa Rica in 2006 to that in 2010?
Your answer should be compact. 1.03. What is the ratio of the Electricity production(% of total) of New Zealand in 2006 to that in 2010?
Ensure brevity in your answer.  0.58. What is the ratio of the Electricity production(% of total) of South Asia in 2006 to that in 2011?
Your answer should be compact. 0.48. What is the ratio of the Electricity production(% of total) in Cameroon in 2006 to that in 2011?
Offer a very short reply. 12.55. What is the ratio of the Electricity production(% of total) in Costa Rica in 2006 to that in 2011?
Provide a succinct answer. 0.96. What is the ratio of the Electricity production(% of total) of New Zealand in 2006 to that in 2011?
Give a very brief answer. 0.53. What is the ratio of the Electricity production(% of total) of South Asia in 2006 to that in 2012?
Ensure brevity in your answer.  0.43. What is the ratio of the Electricity production(% of total) of Cameroon in 2006 to that in 2012?
Provide a short and direct response. 12.4. What is the ratio of the Electricity production(% of total) in Costa Rica in 2006 to that in 2012?
Offer a very short reply. 0.87. What is the ratio of the Electricity production(% of total) in New Zealand in 2006 to that in 2012?
Your answer should be very brief. 0.52. What is the ratio of the Electricity production(% of total) in South Asia in 2007 to that in 2008?
Make the answer very short. 0.85. What is the ratio of the Electricity production(% of total) in Cameroon in 2007 to that in 2008?
Give a very brief answer. 1.07. What is the ratio of the Electricity production(% of total) in Costa Rica in 2007 to that in 2008?
Offer a very short reply. 1.16. What is the ratio of the Electricity production(% of total) in New Zealand in 2007 to that in 2008?
Provide a short and direct response. 0.87. What is the ratio of the Electricity production(% of total) of South Asia in 2007 to that in 2009?
Make the answer very short. 0.7. What is the ratio of the Electricity production(% of total) of Cameroon in 2007 to that in 2009?
Offer a very short reply. 1.18. What is the ratio of the Electricity production(% of total) in Costa Rica in 2007 to that in 2009?
Give a very brief answer. 0.98. What is the ratio of the Electricity production(% of total) of New Zealand in 2007 to that in 2009?
Ensure brevity in your answer.  0.72. What is the ratio of the Electricity production(% of total) of South Asia in 2007 to that in 2010?
Give a very brief answer. 0.66. What is the ratio of the Electricity production(% of total) in Cameroon in 2007 to that in 2010?
Your answer should be compact. 1.45. What is the ratio of the Electricity production(% of total) of Costa Rica in 2007 to that in 2010?
Your answer should be very brief. 0.98. What is the ratio of the Electricity production(% of total) of New Zealand in 2007 to that in 2010?
Offer a terse response. 0.64. What is the ratio of the Electricity production(% of total) of South Asia in 2007 to that in 2011?
Provide a succinct answer. 0.58. What is the ratio of the Electricity production(% of total) of Cameroon in 2007 to that in 2011?
Your answer should be very brief. 1.44. What is the ratio of the Electricity production(% of total) in Costa Rica in 2007 to that in 2011?
Provide a succinct answer. 0.92. What is the ratio of the Electricity production(% of total) of New Zealand in 2007 to that in 2011?
Your answer should be compact. 0.59. What is the ratio of the Electricity production(% of total) of South Asia in 2007 to that in 2012?
Ensure brevity in your answer.  0.51. What is the ratio of the Electricity production(% of total) of Cameroon in 2007 to that in 2012?
Your answer should be compact. 1.43. What is the ratio of the Electricity production(% of total) of Costa Rica in 2007 to that in 2012?
Give a very brief answer. 0.83. What is the ratio of the Electricity production(% of total) in New Zealand in 2007 to that in 2012?
Your answer should be compact. 0.57. What is the ratio of the Electricity production(% of total) of South Asia in 2008 to that in 2009?
Your answer should be compact. 0.82. What is the ratio of the Electricity production(% of total) of Cameroon in 2008 to that in 2009?
Your answer should be compact. 1.1. What is the ratio of the Electricity production(% of total) of Costa Rica in 2008 to that in 2009?
Give a very brief answer. 0.85. What is the ratio of the Electricity production(% of total) in New Zealand in 2008 to that in 2009?
Offer a very short reply. 0.83. What is the ratio of the Electricity production(% of total) of South Asia in 2008 to that in 2010?
Your response must be concise. 0.78. What is the ratio of the Electricity production(% of total) of Cameroon in 2008 to that in 2010?
Your answer should be compact. 1.36. What is the ratio of the Electricity production(% of total) of Costa Rica in 2008 to that in 2010?
Offer a terse response. 0.85. What is the ratio of the Electricity production(% of total) of New Zealand in 2008 to that in 2010?
Give a very brief answer. 0.73. What is the ratio of the Electricity production(% of total) in South Asia in 2008 to that in 2011?
Provide a succinct answer. 0.68. What is the ratio of the Electricity production(% of total) of Cameroon in 2008 to that in 2011?
Provide a short and direct response. 1.35. What is the ratio of the Electricity production(% of total) of Costa Rica in 2008 to that in 2011?
Offer a terse response. 0.8. What is the ratio of the Electricity production(% of total) of New Zealand in 2008 to that in 2011?
Ensure brevity in your answer.  0.68. What is the ratio of the Electricity production(% of total) in South Asia in 2008 to that in 2012?
Offer a very short reply. 0.6. What is the ratio of the Electricity production(% of total) in Cameroon in 2008 to that in 2012?
Make the answer very short. 1.33. What is the ratio of the Electricity production(% of total) in Costa Rica in 2008 to that in 2012?
Your answer should be compact. 0.72. What is the ratio of the Electricity production(% of total) in New Zealand in 2008 to that in 2012?
Offer a terse response. 0.66. What is the ratio of the Electricity production(% of total) in South Asia in 2009 to that in 2010?
Give a very brief answer. 0.95. What is the ratio of the Electricity production(% of total) in Cameroon in 2009 to that in 2010?
Offer a very short reply. 1.23. What is the ratio of the Electricity production(% of total) of Costa Rica in 2009 to that in 2010?
Provide a succinct answer. 1. What is the ratio of the Electricity production(% of total) of New Zealand in 2009 to that in 2010?
Offer a very short reply. 0.88. What is the ratio of the Electricity production(% of total) in South Asia in 2009 to that in 2011?
Provide a short and direct response. 0.83. What is the ratio of the Electricity production(% of total) of Cameroon in 2009 to that in 2011?
Give a very brief answer. 1.22. What is the ratio of the Electricity production(% of total) of Costa Rica in 2009 to that in 2011?
Your response must be concise. 0.94. What is the ratio of the Electricity production(% of total) in New Zealand in 2009 to that in 2011?
Provide a short and direct response. 0.82. What is the ratio of the Electricity production(% of total) of South Asia in 2009 to that in 2012?
Give a very brief answer. 0.73. What is the ratio of the Electricity production(% of total) in Cameroon in 2009 to that in 2012?
Make the answer very short. 1.21. What is the ratio of the Electricity production(% of total) in Costa Rica in 2009 to that in 2012?
Ensure brevity in your answer.  0.85. What is the ratio of the Electricity production(% of total) in New Zealand in 2009 to that in 2012?
Provide a succinct answer. 0.79. What is the ratio of the Electricity production(% of total) of South Asia in 2010 to that in 2011?
Provide a short and direct response. 0.87. What is the ratio of the Electricity production(% of total) in Cameroon in 2010 to that in 2011?
Provide a short and direct response. 1. What is the ratio of the Electricity production(% of total) of Costa Rica in 2010 to that in 2011?
Your answer should be very brief. 0.94. What is the ratio of the Electricity production(% of total) in New Zealand in 2010 to that in 2011?
Ensure brevity in your answer.  0.92. What is the ratio of the Electricity production(% of total) of South Asia in 2010 to that in 2012?
Your response must be concise. 0.77. What is the ratio of the Electricity production(% of total) in Cameroon in 2010 to that in 2012?
Offer a very short reply. 0.98. What is the ratio of the Electricity production(% of total) of Costa Rica in 2010 to that in 2012?
Ensure brevity in your answer.  0.84. What is the ratio of the Electricity production(% of total) of New Zealand in 2010 to that in 2012?
Ensure brevity in your answer.  0.9. What is the ratio of the Electricity production(% of total) of South Asia in 2011 to that in 2012?
Make the answer very short. 0.89. What is the ratio of the Electricity production(% of total) in Cameroon in 2011 to that in 2012?
Keep it short and to the point. 0.99. What is the ratio of the Electricity production(% of total) of Costa Rica in 2011 to that in 2012?
Ensure brevity in your answer.  0.9. What is the ratio of the Electricity production(% of total) of New Zealand in 2011 to that in 2012?
Your answer should be very brief. 0.97. What is the difference between the highest and the second highest Electricity production(% of total) of South Asia?
Keep it short and to the point. 0.45. What is the difference between the highest and the second highest Electricity production(% of total) of Cameroon?
Offer a very short reply. 11.14. What is the difference between the highest and the second highest Electricity production(% of total) in Costa Rica?
Provide a succinct answer. 2.09. What is the difference between the highest and the second highest Electricity production(% of total) of New Zealand?
Make the answer very short. 0.53. What is the difference between the highest and the lowest Electricity production(% of total) of South Asia?
Ensure brevity in your answer.  2.22. What is the difference between the highest and the lowest Electricity production(% of total) of Cameroon?
Make the answer very short. 11.59. What is the difference between the highest and the lowest Electricity production(% of total) in Costa Rica?
Give a very brief answer. 5.86. What is the difference between the highest and the lowest Electricity production(% of total) of New Zealand?
Your answer should be very brief. 9.67. 